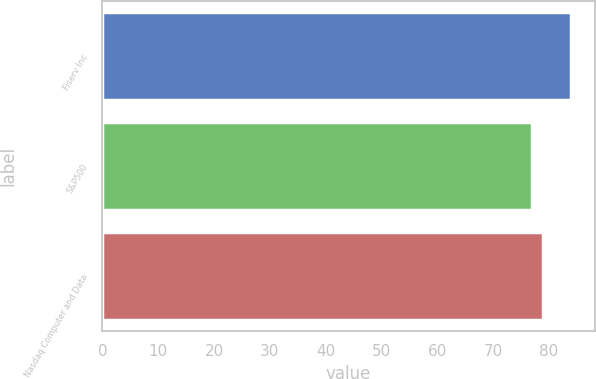Convert chart. <chart><loc_0><loc_0><loc_500><loc_500><bar_chart><fcel>Fiserv Inc<fcel>S&P500<fcel>Nasdaq Computer and Data<nl><fcel>84<fcel>77<fcel>79<nl></chart> 